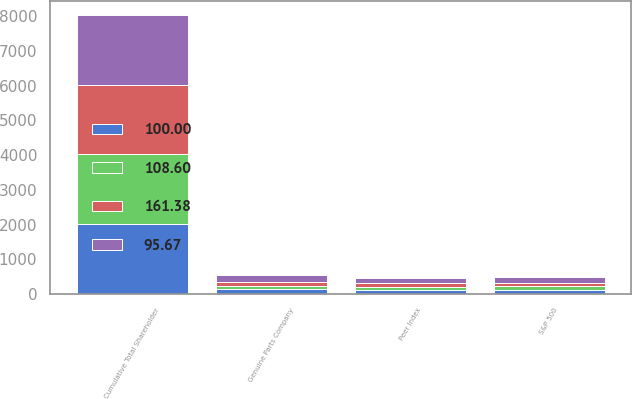<chart> <loc_0><loc_0><loc_500><loc_500><stacked_bar_chart><ecel><fcel>Cumulative Total Shareholder<fcel>Genuine Parts Company<fcel>S&P 500<fcel>Peer Index<nl><fcel>108.6<fcel>2010<fcel>100<fcel>100<fcel>100<nl><fcel>161.38<fcel>2011<fcel>123.27<fcel>102.11<fcel>95.67<nl><fcel>100<fcel>2012<fcel>132.23<fcel>118.45<fcel>108.6<nl><fcel>95.67<fcel>2013<fcel>177.9<fcel>156.81<fcel>155.29<nl></chart> 